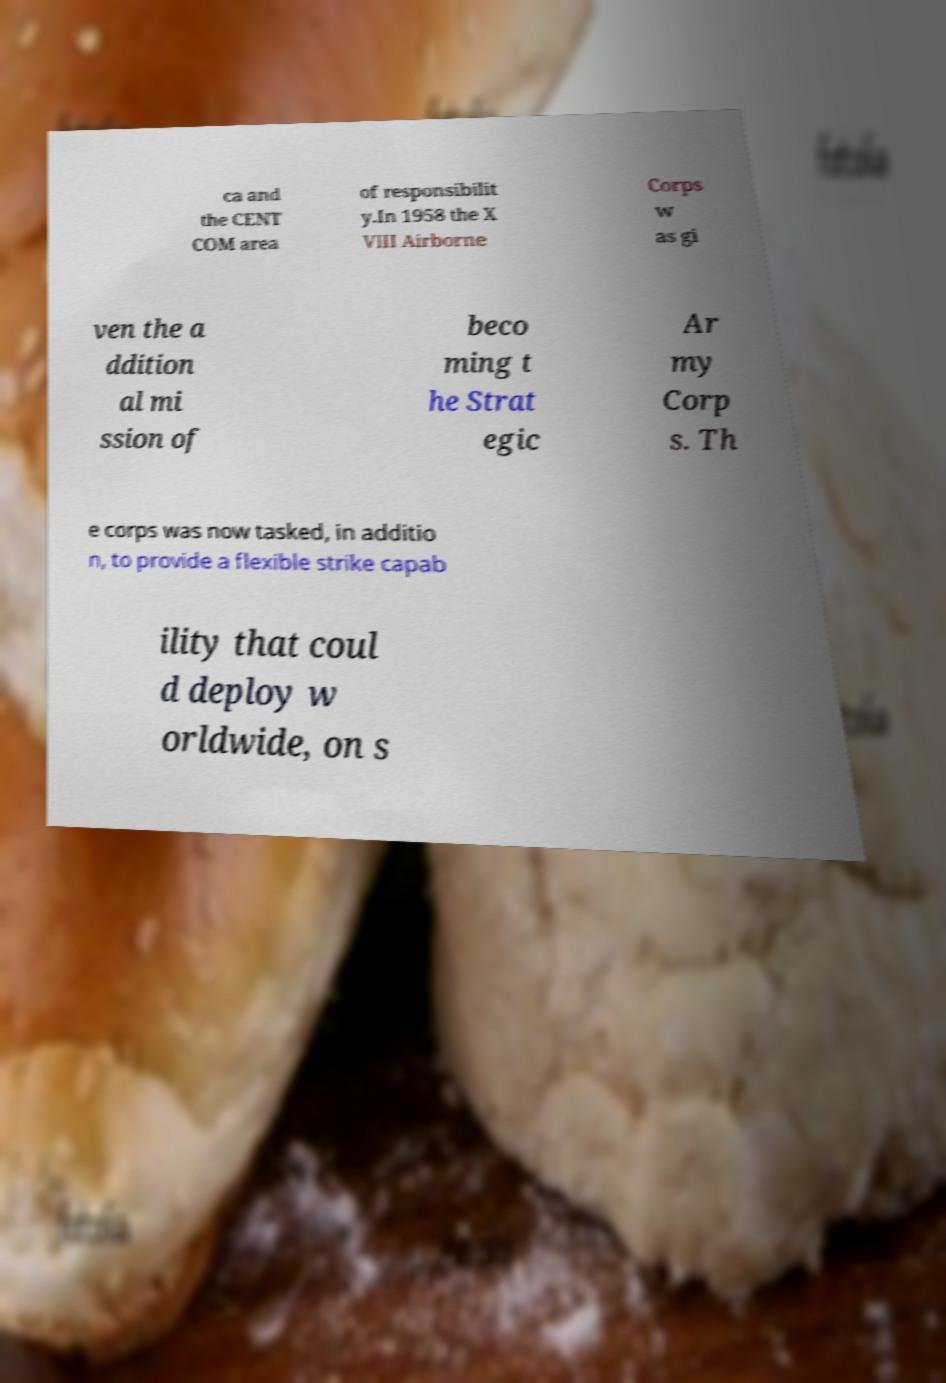I need the written content from this picture converted into text. Can you do that? ca and the CENT COM area of responsibilit y.In 1958 the X VIII Airborne Corps w as gi ven the a ddition al mi ssion of beco ming t he Strat egic Ar my Corp s. Th e corps was now tasked, in additio n, to provide a flexible strike capab ility that coul d deploy w orldwide, on s 